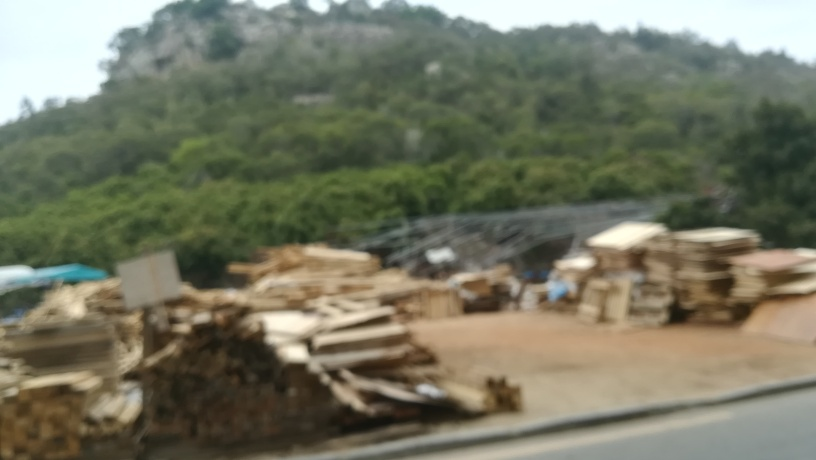What is the overall clarity of the image? The clarity of the image is quite low. It appears to be taken with a slow shutter speed or while in motion, leading to a significant amount of motion blur. This blur affects the entire image, making it difficult to discern fine details or identify specific objects accurately. 